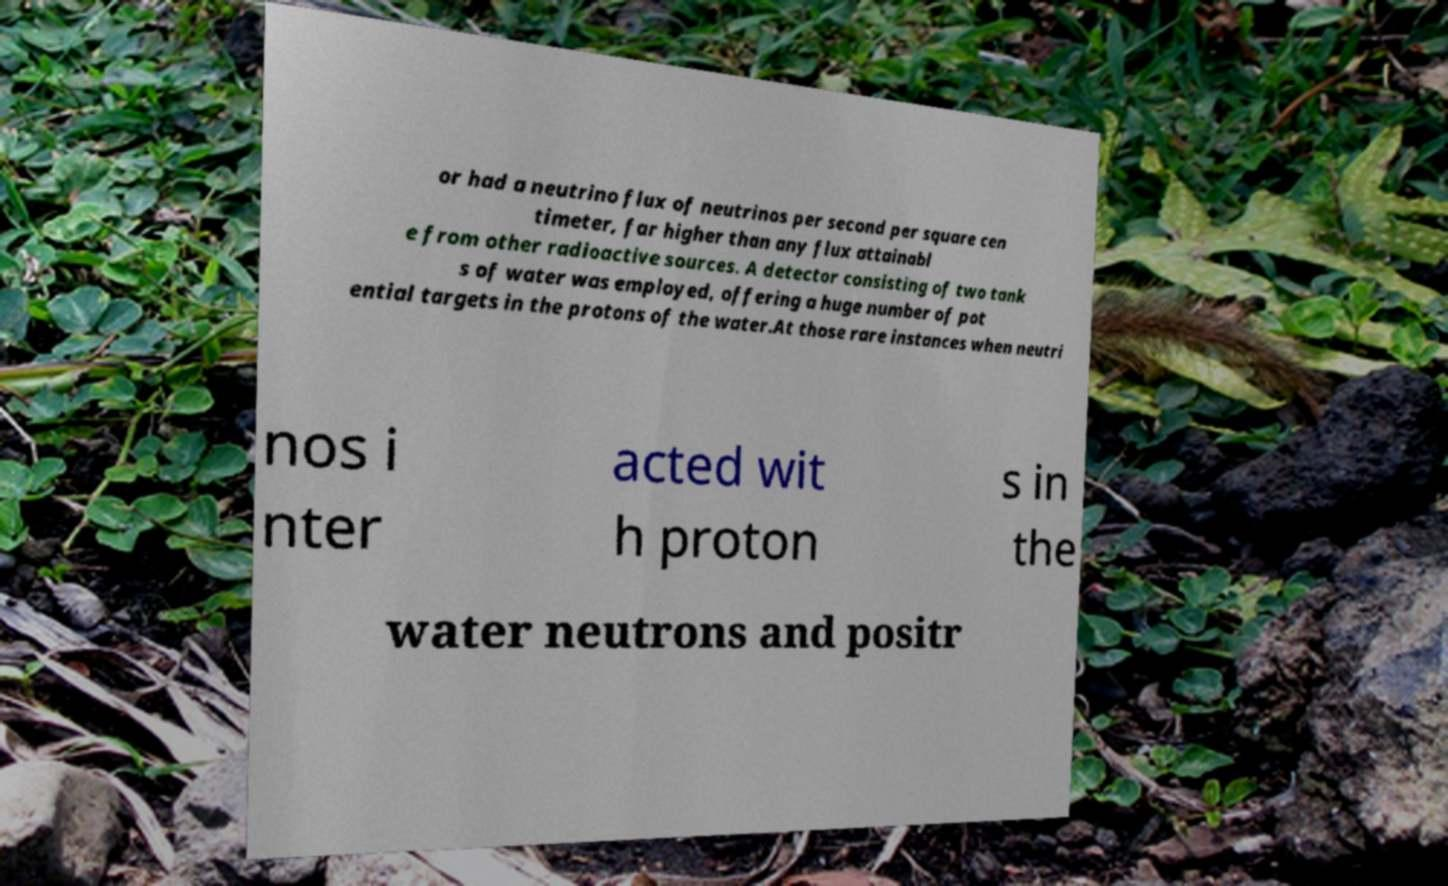There's text embedded in this image that I need extracted. Can you transcribe it verbatim? or had a neutrino flux of neutrinos per second per square cen timeter, far higher than any flux attainabl e from other radioactive sources. A detector consisting of two tank s of water was employed, offering a huge number of pot ential targets in the protons of the water.At those rare instances when neutri nos i nter acted wit h proton s in the water neutrons and positr 